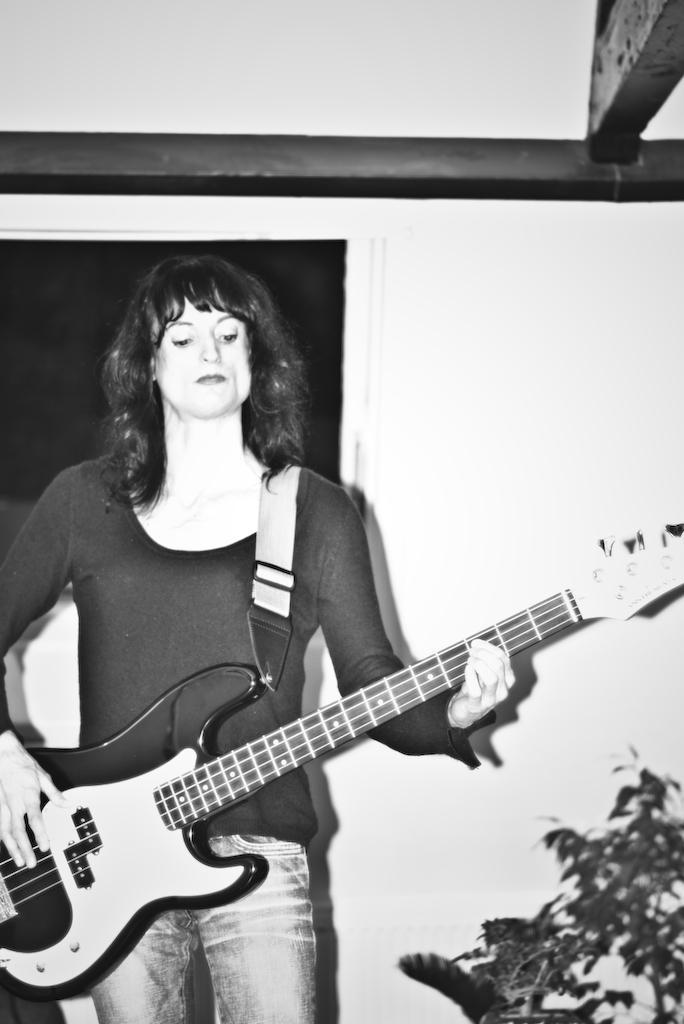Can you describe this image briefly? In the image we can see one woman standing and holding guitar. In the background there is a board,plant and light. 